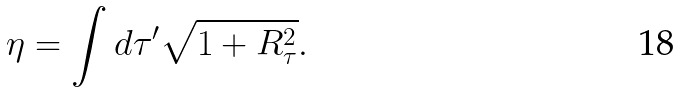Convert formula to latex. <formula><loc_0><loc_0><loc_500><loc_500>\eta = \int d \tau ^ { \prime } \sqrt { 1 + R _ { \tau } ^ { 2 } } .</formula> 